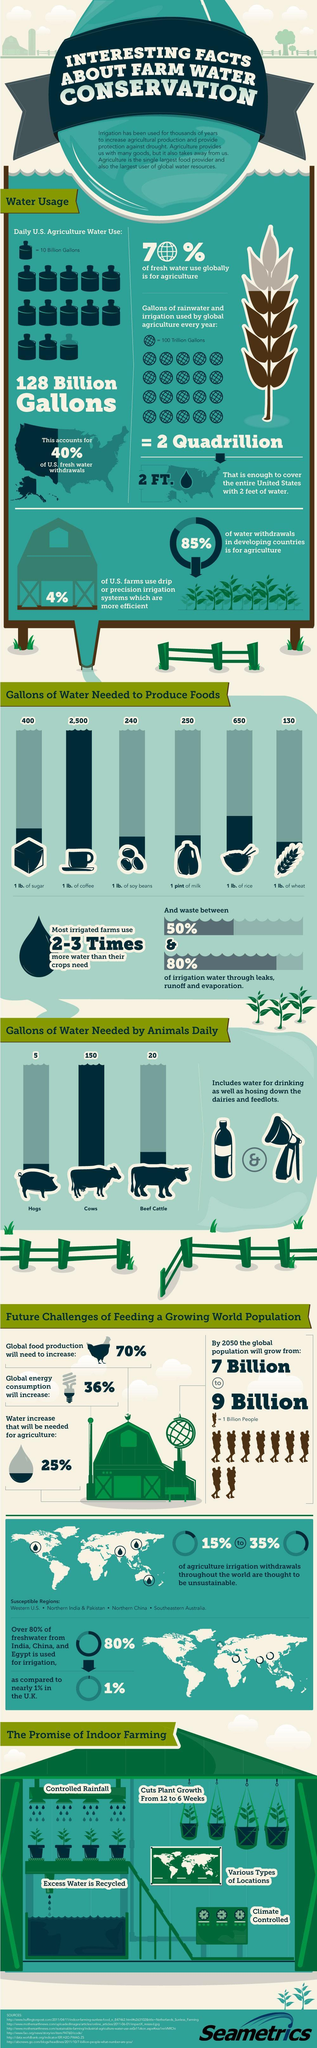How many gallons of water is required to produce 0.45 kg of coffee?
Answer the question with a short phrase. 2500 How much less water does a beef cattle need in comparison to cows? 130 gallons What is the amount of water consumed by pigs everyday? 5 gallons Which crop require the least amount of water to be produced? wheat By how much does the population increase in 2050, if the current population is 7 billion? 2 Billion How many liters of water is required to grow 0.45 kg of soy beans? 908.4 liters What is the water required to produce 0.47 liters of milk? 250 gallons 